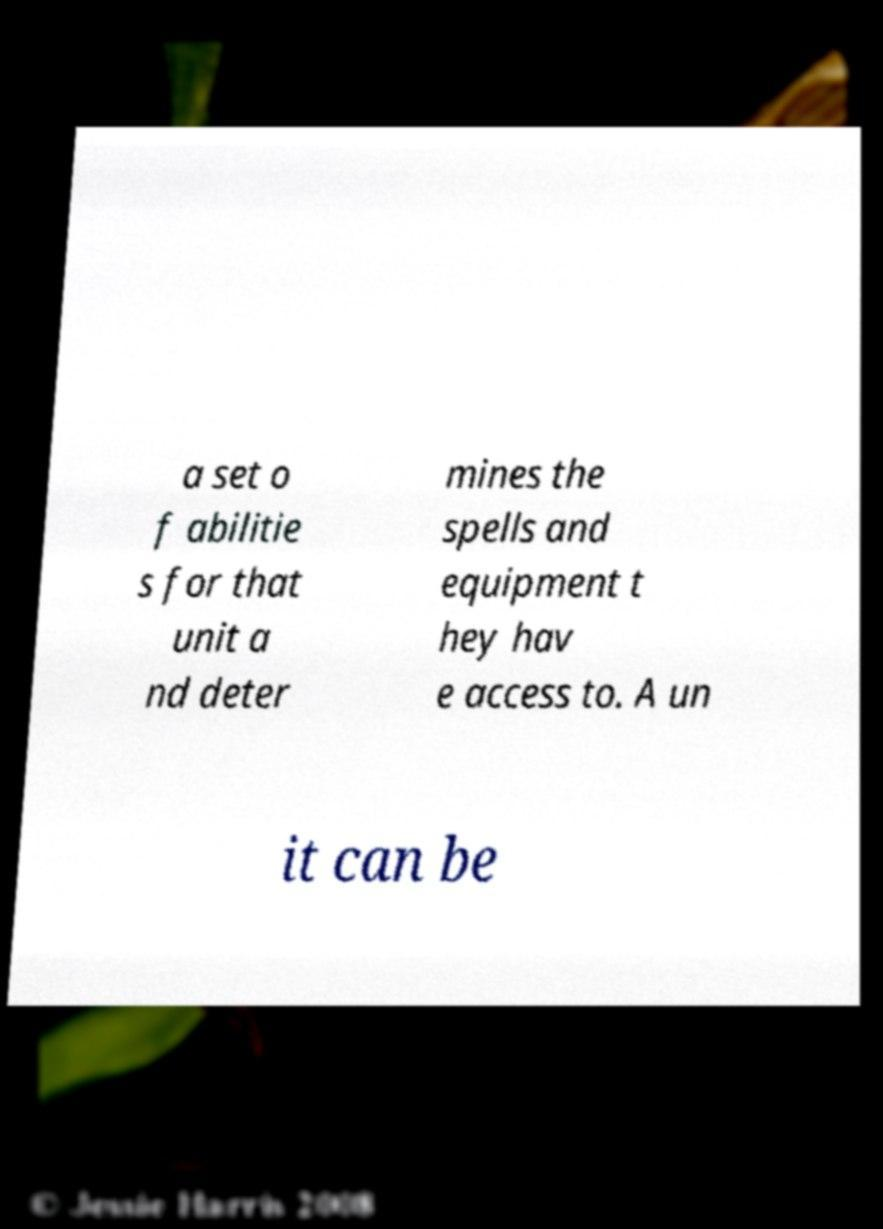Could you extract and type out the text from this image? a set o f abilitie s for that unit a nd deter mines the spells and equipment t hey hav e access to. A un it can be 